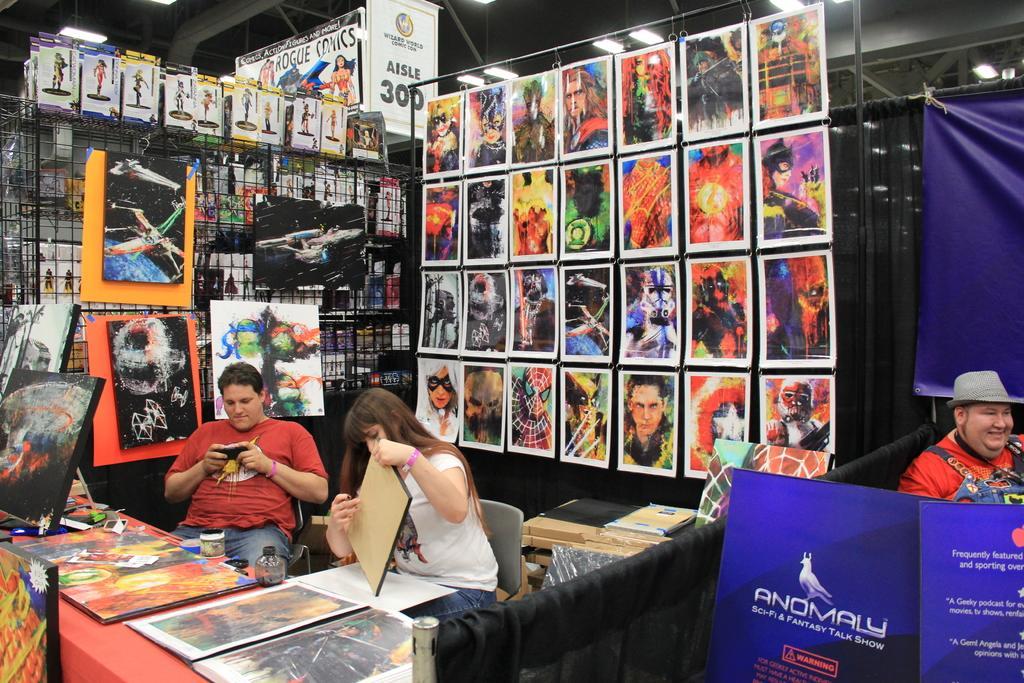Please provide a concise description of this image. In this picture there are three persons sitting. At the right side the person wearing a grey colour hat is having smile on his face. And the blue colour curtain, blue colour board with name and Anomaly. At the left side woman sitting on a chair is doing work and the man wearing red colour shirt is sitting on a chair is playing on his mobile phone. In the front on the table there are frames. In the background posters, boards, stand and book on the table. 